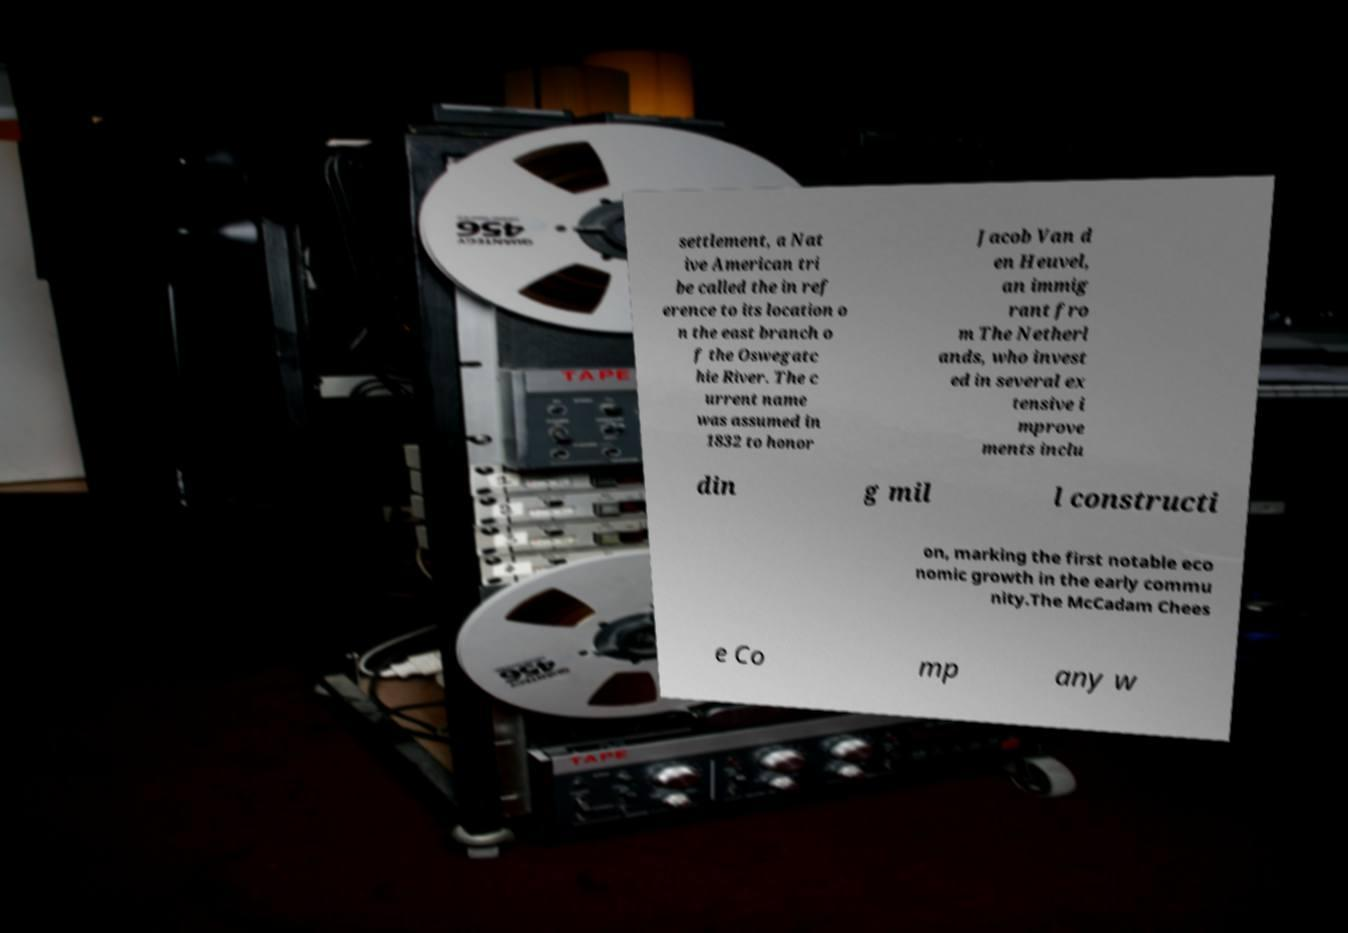Please read and relay the text visible in this image. What does it say? settlement, a Nat ive American tri be called the in ref erence to its location o n the east branch o f the Oswegatc hie River. The c urrent name was assumed in 1832 to honor Jacob Van d en Heuvel, an immig rant fro m The Netherl ands, who invest ed in several ex tensive i mprove ments inclu din g mil l constructi on, marking the first notable eco nomic growth in the early commu nity.The McCadam Chees e Co mp any w 